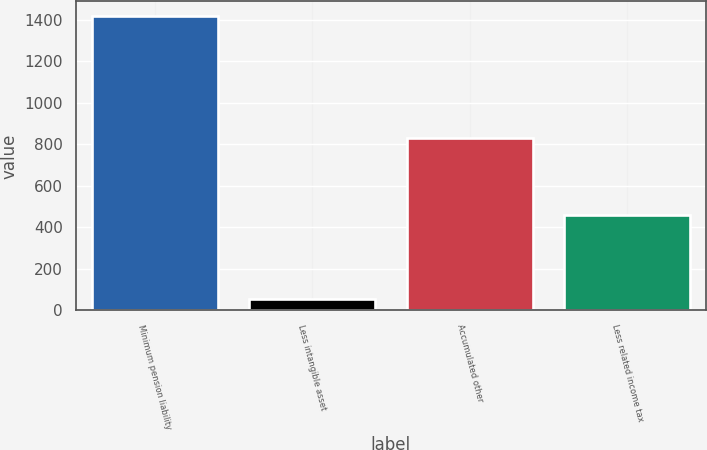Convert chart to OTSL. <chart><loc_0><loc_0><loc_500><loc_500><bar_chart><fcel>Minimum pension liability<fcel>Less intangible asset<fcel>Accumulated other<fcel>Less related income tax<nl><fcel>1417.68<fcel>52.8<fcel>829.6<fcel>459.2<nl></chart> 